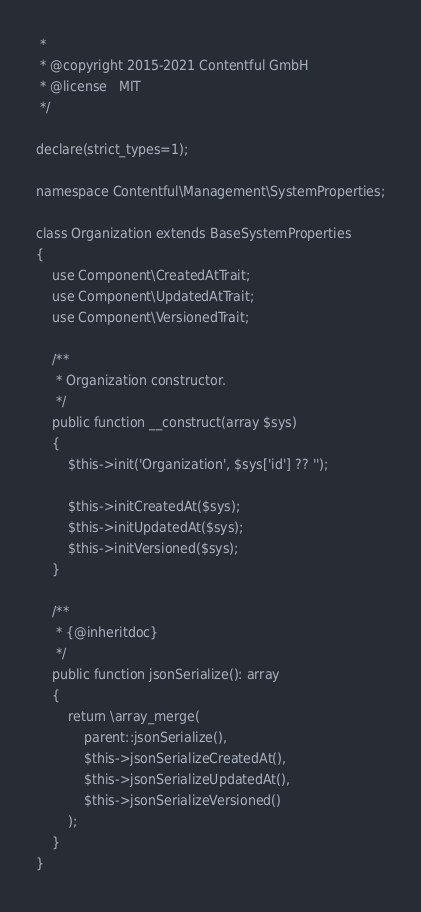Convert code to text. <code><loc_0><loc_0><loc_500><loc_500><_PHP_> *
 * @copyright 2015-2021 Contentful GmbH
 * @license   MIT
 */

declare(strict_types=1);

namespace Contentful\Management\SystemProperties;

class Organization extends BaseSystemProperties
{
    use Component\CreatedAtTrait;
    use Component\UpdatedAtTrait;
    use Component\VersionedTrait;

    /**
     * Organization constructor.
     */
    public function __construct(array $sys)
    {
        $this->init('Organization', $sys['id'] ?? '');

        $this->initCreatedAt($sys);
        $this->initUpdatedAt($sys);
        $this->initVersioned($sys);
    }

    /**
     * {@inheritdoc}
     */
    public function jsonSerialize(): array
    {
        return \array_merge(
            parent::jsonSerialize(),
            $this->jsonSerializeCreatedAt(),
            $this->jsonSerializeUpdatedAt(),
            $this->jsonSerializeVersioned()
        );
    }
}
</code> 